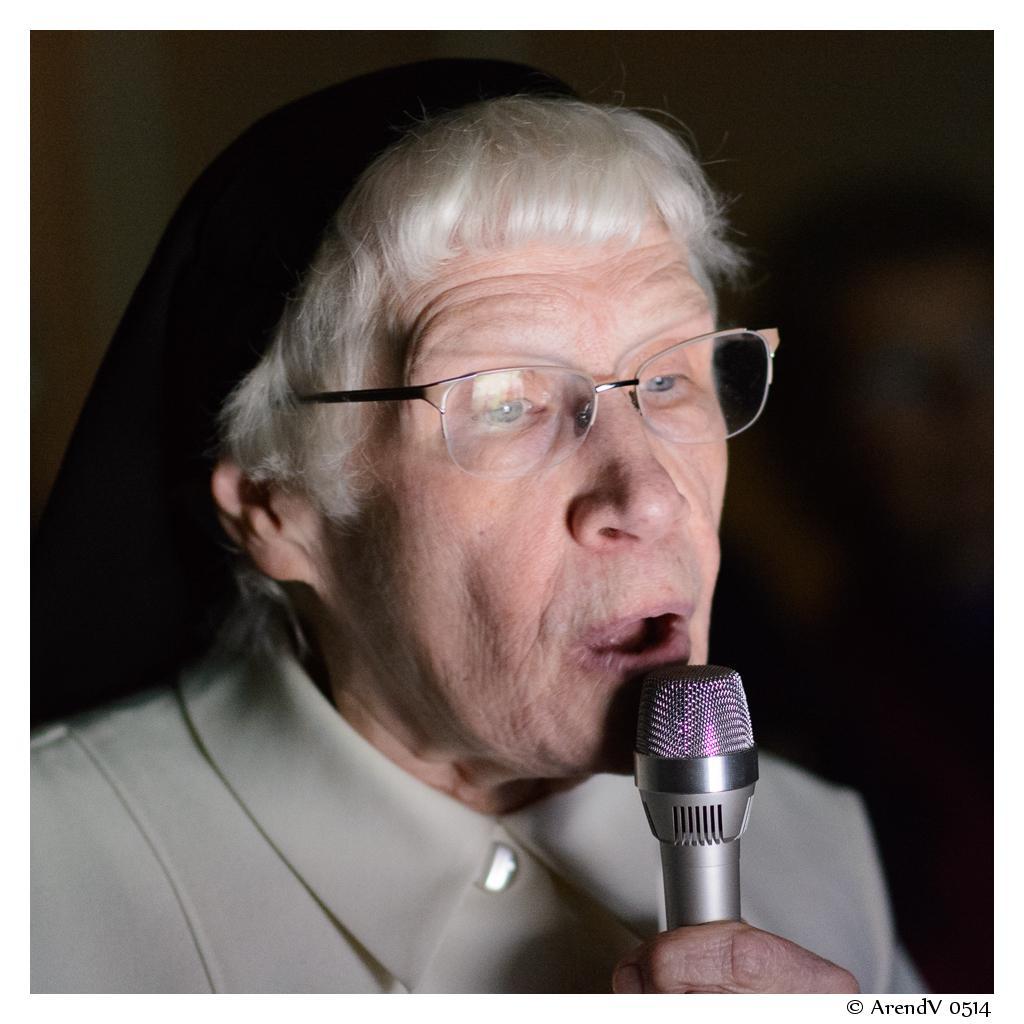Please provide a concise description of this image. In this image there is a person wearing spectacles is holding a mike. 